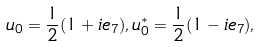<formula> <loc_0><loc_0><loc_500><loc_500>u _ { 0 } = \frac { 1 } { 2 } ( 1 + i e _ { 7 } ) , u _ { 0 } ^ { * } = \frac { 1 } { 2 } ( 1 - i e _ { 7 } ) ,</formula> 